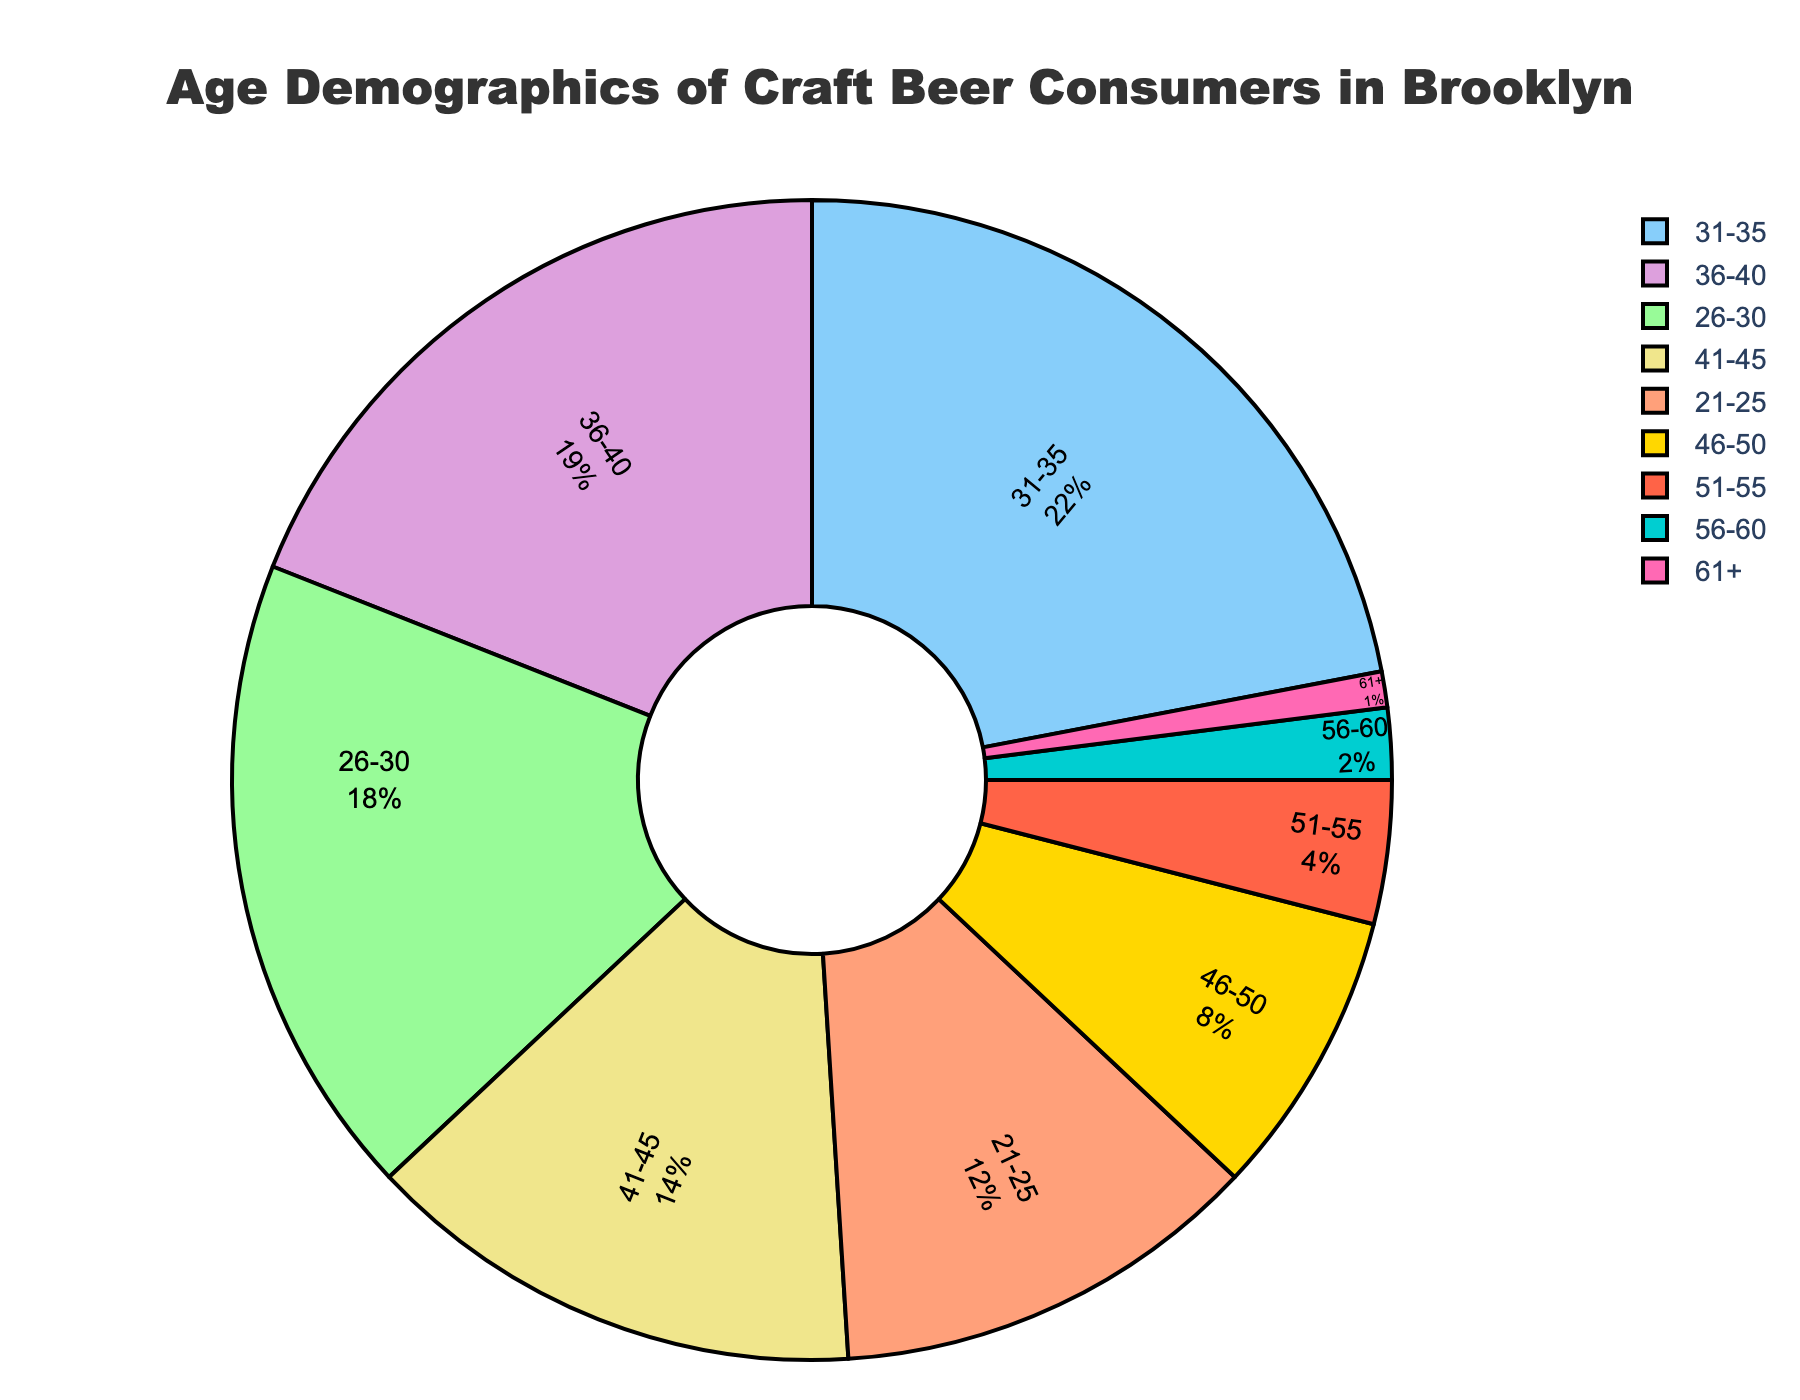What's the most common age group for craft beer consumers in Brooklyn? The largest section of the pie chart corresponds to the 31-35 age group. By observing the chart, it is clear that this age group occupies the largest percentage of 22%.
Answer: 31-35 Which age group has the smallest proportion of craft beer consumers? The smallest slice of the pie chart represents the 61+ age group. This can be identified by its tiny section with a percentage of 1%.
Answer: 61+ How does the percentage of 26-30 year-olds compare to 46-50 year-olds? By looking at the pie chart, the 26-30 age group occupies 18%, while the 46-50 age group occupies 8%. Comparing these percentages, the 26-30 age group is more than twice that of the 46-50 age group.
Answer: 26-30 is more than twice 46-50 What is the combined percentage of consumers aged 36-45? To find the combined percentage, sum the percentages of the 36-40 age group (19%) and the 41-45 age group (14%). So, 19% + 14% = 33%.
Answer: 33% What is the average percentage of consumers from the age groups 51-55, 56-60, and 61+? Add the percentages of these three groups: 51-55 (4%), 56-60 (2%), and 61+ (1%). The sum is 4% + 2% + 1% = 7%. Now, divide by 3 (number of groups) to find the average: 7% / 3 ≈ 2.33%.
Answer: 2.33% Which age group has a higher percentage, 21-25 or 41-45? The 21-25 age group has a percentage of 12%, while the 41-45 age group has a percentage of 14%. Therefore, the 41-45 age group has a higher percentage.
Answer: 41-45 Is the percentage of 31-35 year-old consumers greater than the combined percentage of 46-50 and 51-55 year-olds? The percentage for 31-35 year-olds is 22%. The combined percentage for 46-50 (8%) and 51-55 (4%) is 8% + 4% = 12%. Since 22% is greater than 12%, the 31-35 age group percentage is indeed greater.
Answer: Yes Among the age groups 26-30, 36-40, and 41-45, which one occupies the middle percentage? The percentages for these age groups are: 26-30 (18%), 36-40 (19%), and 41-45 (14%). Arranged in ascending order: 14%, 18%, 19%, the median percentage is 18%, corresponding to the 26-30 age group.
Answer: 26-30 How does the pie chart visually differentiate the age group segments? The pie chart uses different colors for each age group segment and includes labels and percentages inside the slices to clearly show the representation of each group. The varied colors and clear text make it easy to distinguish between groups.
Answer: Different colors and labels What is the cumulative percentage of consumers aged 51 and above? Add the percentages for the age groups 51-55 (4%), 56-60 (2%), and 61+ (1%). Thus, the cumulative percentage is 4% + 2% + 1% = 7%.
Answer: 7% 